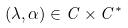<formula> <loc_0><loc_0><loc_500><loc_500>( \lambda , \alpha ) \in C \times C ^ { * }</formula> 